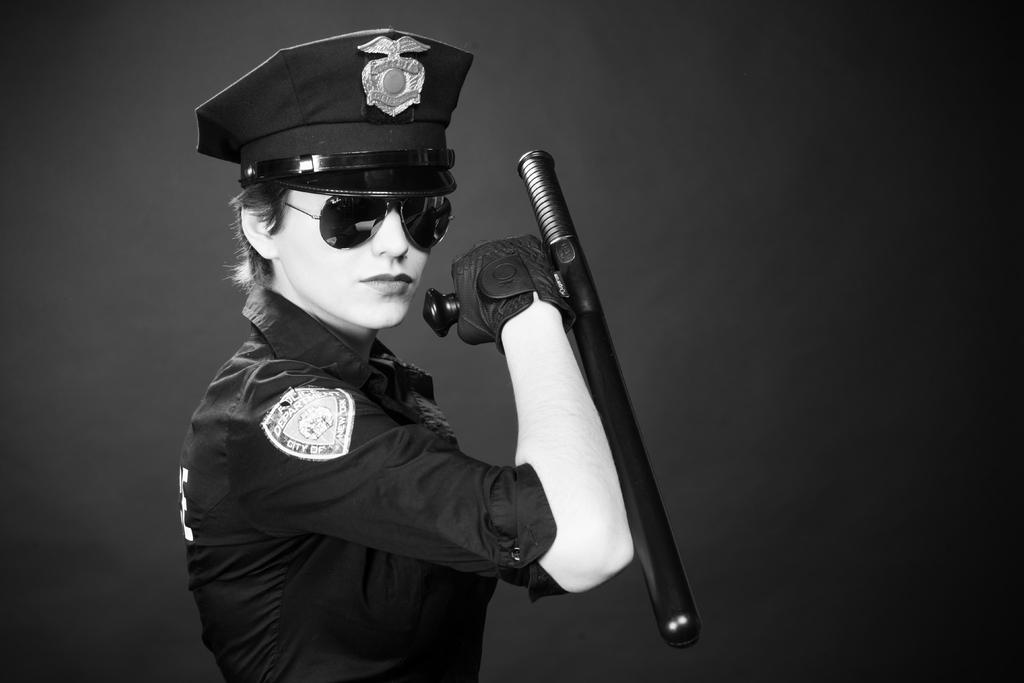Who is the main subject in the image? There is a girl in the image. What is the girl wearing? The girl is wearing a uniform. What is the girl holding in the image? The girl is holding an object. What part of the image is in focus? The foreground area of the image is focused on the girl. What is the color of the background in the image? The background of the image is black. What type of lawyer is the girl representing in the image? There is no indication in the image that the girl is a lawyer or representing anyone. 